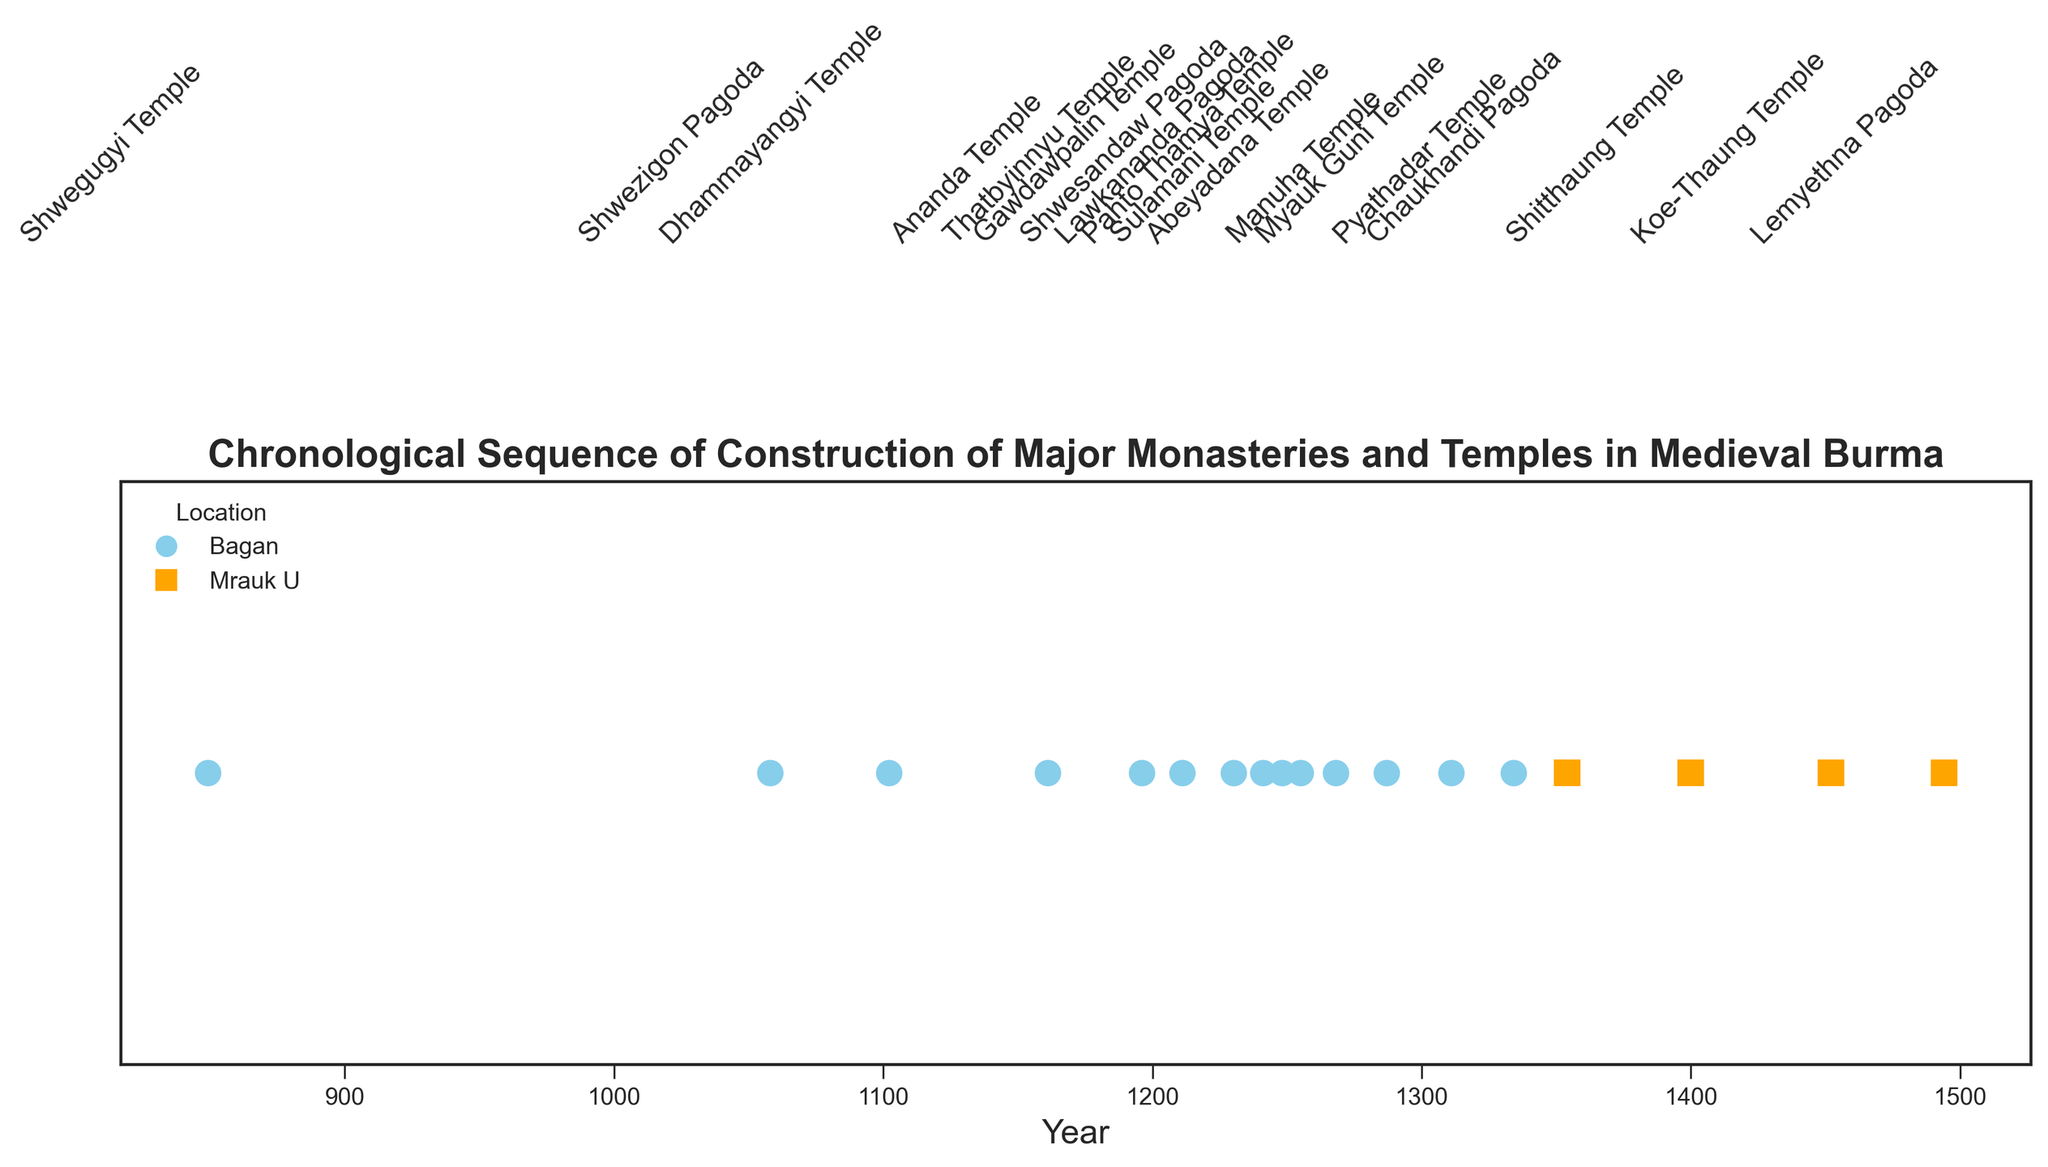Which location has more structures shown in the figure? By observing the different markers, the figure shows more structures in Bagan than in Mrauk U.
Answer: Bagan What is the most recent structure built in Bagan according to the figure? By looking at the most recent date for structures in Bagan, we see Pyathadar Temple was built in 1334.
Answer: Pyathadar Temple Which structure was built first in Mrauk U? The figure shows that Chaukhandi Pagoda was built first in Mrauk U in 1354.
Answer: Chaukhandi Pagoda Which structure was constructed closest in time to Ananda Temple? By looking for the structure nearest in year to Ananda Temple (1161), Dhammayangyi Temple (1102) is the closest in time.
Answer: Dhammayangyi Temple How many structures were constructed before the year 1300? Observing the dates, we see 11 structures (Shwegugyi Temple, Shwezigon Pagoda, Dhammayangyi Temple, Ananda Temple, Thatbyinnyu Temple, Gawdawpalin Temple, Shwesandaw Pagoda, Lawkananda Pagoda, Sulamani Temple, Pahto Thamya Temple, Abeyadana Temple) were built before 1300.
Answer: 11 Which structure built in Mrauk U has the most recent construction date? The figure indicates Lemyethna Pagoda, built in 1494, is the most recently constructed structure in Mrauk U.
Answer: Lemyethna Pagoda What is the average year of construction for the structures in Bagan? Summing the years for Bagan structures (849, 1058, 1102, 1161, 1196, 1211, 1230, 1241, 1248, 1255, 1268, 1287, 1311, 1334) and dividing by the number of structures (14) gives an average of (849+1058+1102+1161+1196+1211+1230+1241+1248+1255+1268+1287+1311+1334)/14 = 1171
Answer: 1171 